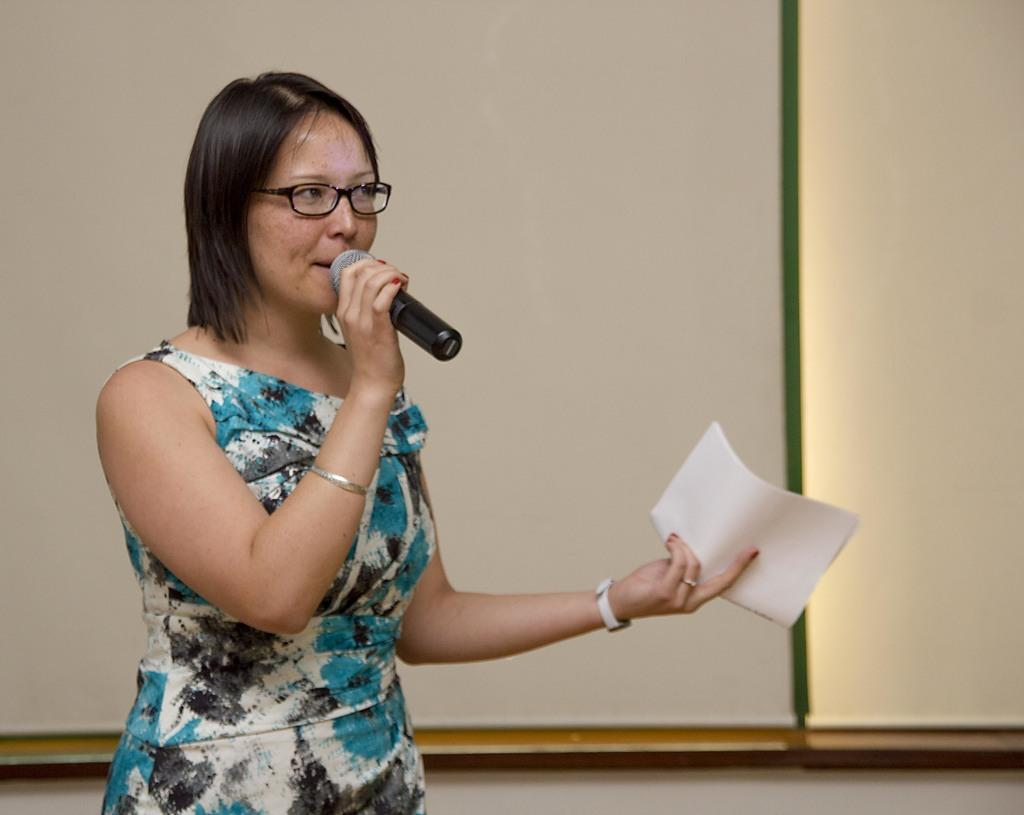Who is the main subject in the image? There is a woman in the image. What is the woman holding in one hand? The woman is holding a mic in one hand. What is the woman holding in the other hand? The woman is holding papers in the other hand. What is the woman doing in the image? The woman is delivering a speech. What can be seen behind the woman? There is a screen behind the woman. What type of loaf is the woman using to deliver her speech? A: There is no loaf present in the image; the woman is using a mic to deliver her speech. Can you see any cattle in the image? There are no cattle present in the image. 